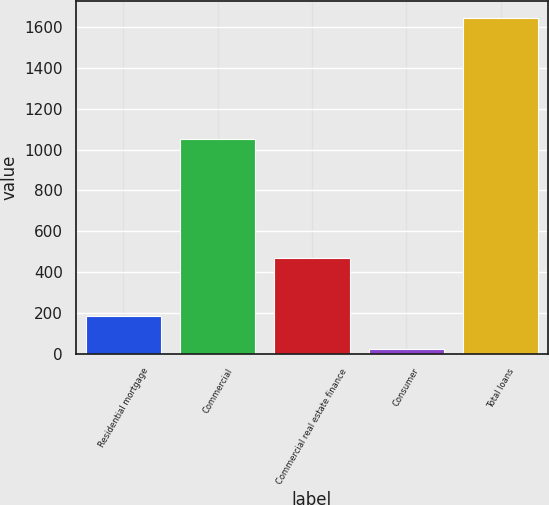Convert chart to OTSL. <chart><loc_0><loc_0><loc_500><loc_500><bar_chart><fcel>Residential mortgage<fcel>Commercial<fcel>Commercial real estate finance<fcel>Consumer<fcel>Total loans<nl><fcel>185.43<fcel>1051.1<fcel>469.4<fcel>23.2<fcel>1645.5<nl></chart> 